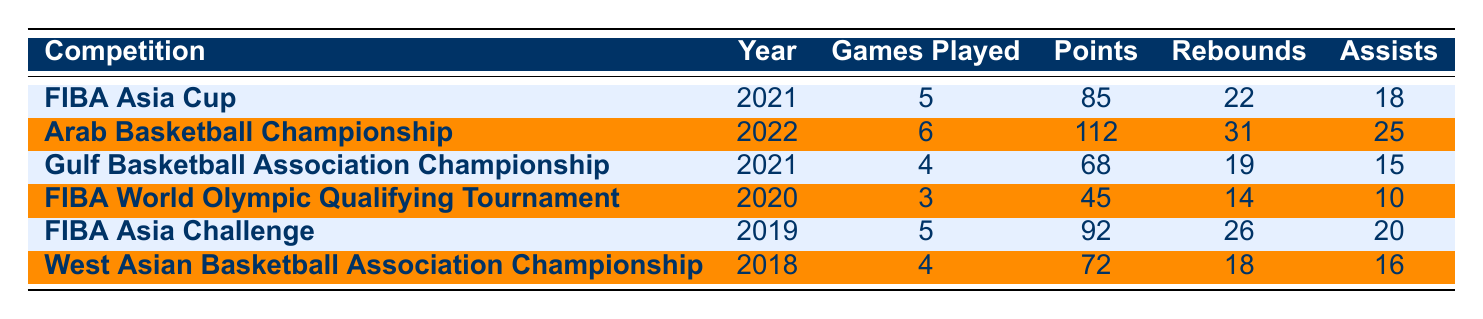What was Ahmed Hassan Al-Derazi's highest points scored in a single competition? The table shows that in the Arab Basketball Championship of 2022, he scored 112 points, which is the highest among all the competitions listed.
Answer: 112 In which year did Ahmed Hassan Al-Derazi play the most games? By examining the "Games Played" column, he played 6 games in the Arab Basketball Championship in 2022, which is more than any other event listed.
Answer: 2022 What is the total number of rebounds Ahmed Hassan Al-Derazi had across all competitions? Summing the rebounds from each row: 22 + 31 + 19 + 14 + 26 + 18 = 130. Thus, the total rebounds he collected across all competitions is 130.
Answer: 130 Did Ahmed Hassan Al-Derazi score more points in the FIBA Asia Challenge than in the Gulf Basketball Association Championship? In the FIBA Asia Challenge, he scored 92 points, while in the Gulf Basketball Association Championship, he scored 68 points. Since 92 is greater than 68, the answer is yes.
Answer: Yes What is the average number of assists per game played for Ahmed Hassan Al-Derazi across all competitions? The total assists are 18 + 25 + 15 + 10 + 20 + 16 = 114. The total games played are 5 + 6 + 4 + 3 + 5 + 4 = 27. Therefore, the average assists per game is 114 / 27 ≈ 4.22.
Answer: 4.22 Which competition had the least total points scored by Ahmed Hassan Al-Derazi? Looking at the "Points" column, the FIBA World Olympic Qualifying Tournament in 2020 had the least total points scored with 45 points.
Answer: 45 Was the performance in the Arab Basketball Championship better than in the FIBA World Olympic Qualifying Tournament based on points scored? In the Arab Championship, he scored 112 points, while in the World Olympic Qualifying Tournament, he scored 45 points. Since 112 is greater than 45, the performance was better in the Arab Championship.
Answer: Yes 